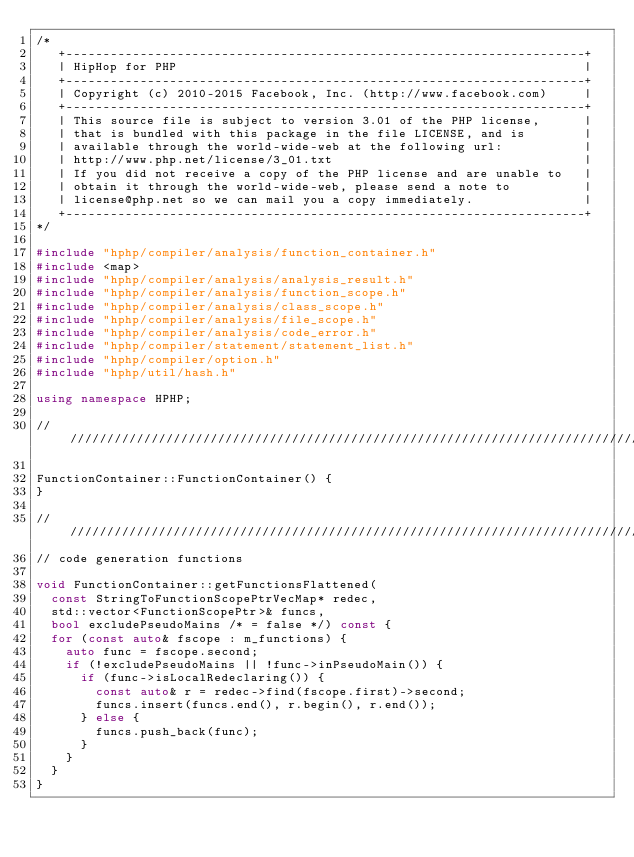<code> <loc_0><loc_0><loc_500><loc_500><_C++_>/*
   +----------------------------------------------------------------------+
   | HipHop for PHP                                                       |
   +----------------------------------------------------------------------+
   | Copyright (c) 2010-2015 Facebook, Inc. (http://www.facebook.com)     |
   +----------------------------------------------------------------------+
   | This source file is subject to version 3.01 of the PHP license,      |
   | that is bundled with this package in the file LICENSE, and is        |
   | available through the world-wide-web at the following url:           |
   | http://www.php.net/license/3_01.txt                                  |
   | If you did not receive a copy of the PHP license and are unable to   |
   | obtain it through the world-wide-web, please send a note to          |
   | license@php.net so we can mail you a copy immediately.               |
   +----------------------------------------------------------------------+
*/

#include "hphp/compiler/analysis/function_container.h"
#include <map>
#include "hphp/compiler/analysis/analysis_result.h"
#include "hphp/compiler/analysis/function_scope.h"
#include "hphp/compiler/analysis/class_scope.h"
#include "hphp/compiler/analysis/file_scope.h"
#include "hphp/compiler/analysis/code_error.h"
#include "hphp/compiler/statement/statement_list.h"
#include "hphp/compiler/option.h"
#include "hphp/util/hash.h"

using namespace HPHP;

///////////////////////////////////////////////////////////////////////////////

FunctionContainer::FunctionContainer() {
}

///////////////////////////////////////////////////////////////////////////////
// code generation functions

void FunctionContainer::getFunctionsFlattened(
  const StringToFunctionScopePtrVecMap* redec,
  std::vector<FunctionScopePtr>& funcs,
  bool excludePseudoMains /* = false */) const {
  for (const auto& fscope : m_functions) {
    auto func = fscope.second;
    if (!excludePseudoMains || !func->inPseudoMain()) {
      if (func->isLocalRedeclaring()) {
        const auto& r = redec->find(fscope.first)->second;
        funcs.insert(funcs.end(), r.begin(), r.end());
      } else {
        funcs.push_back(func);
      }
    }
  }
}
</code> 